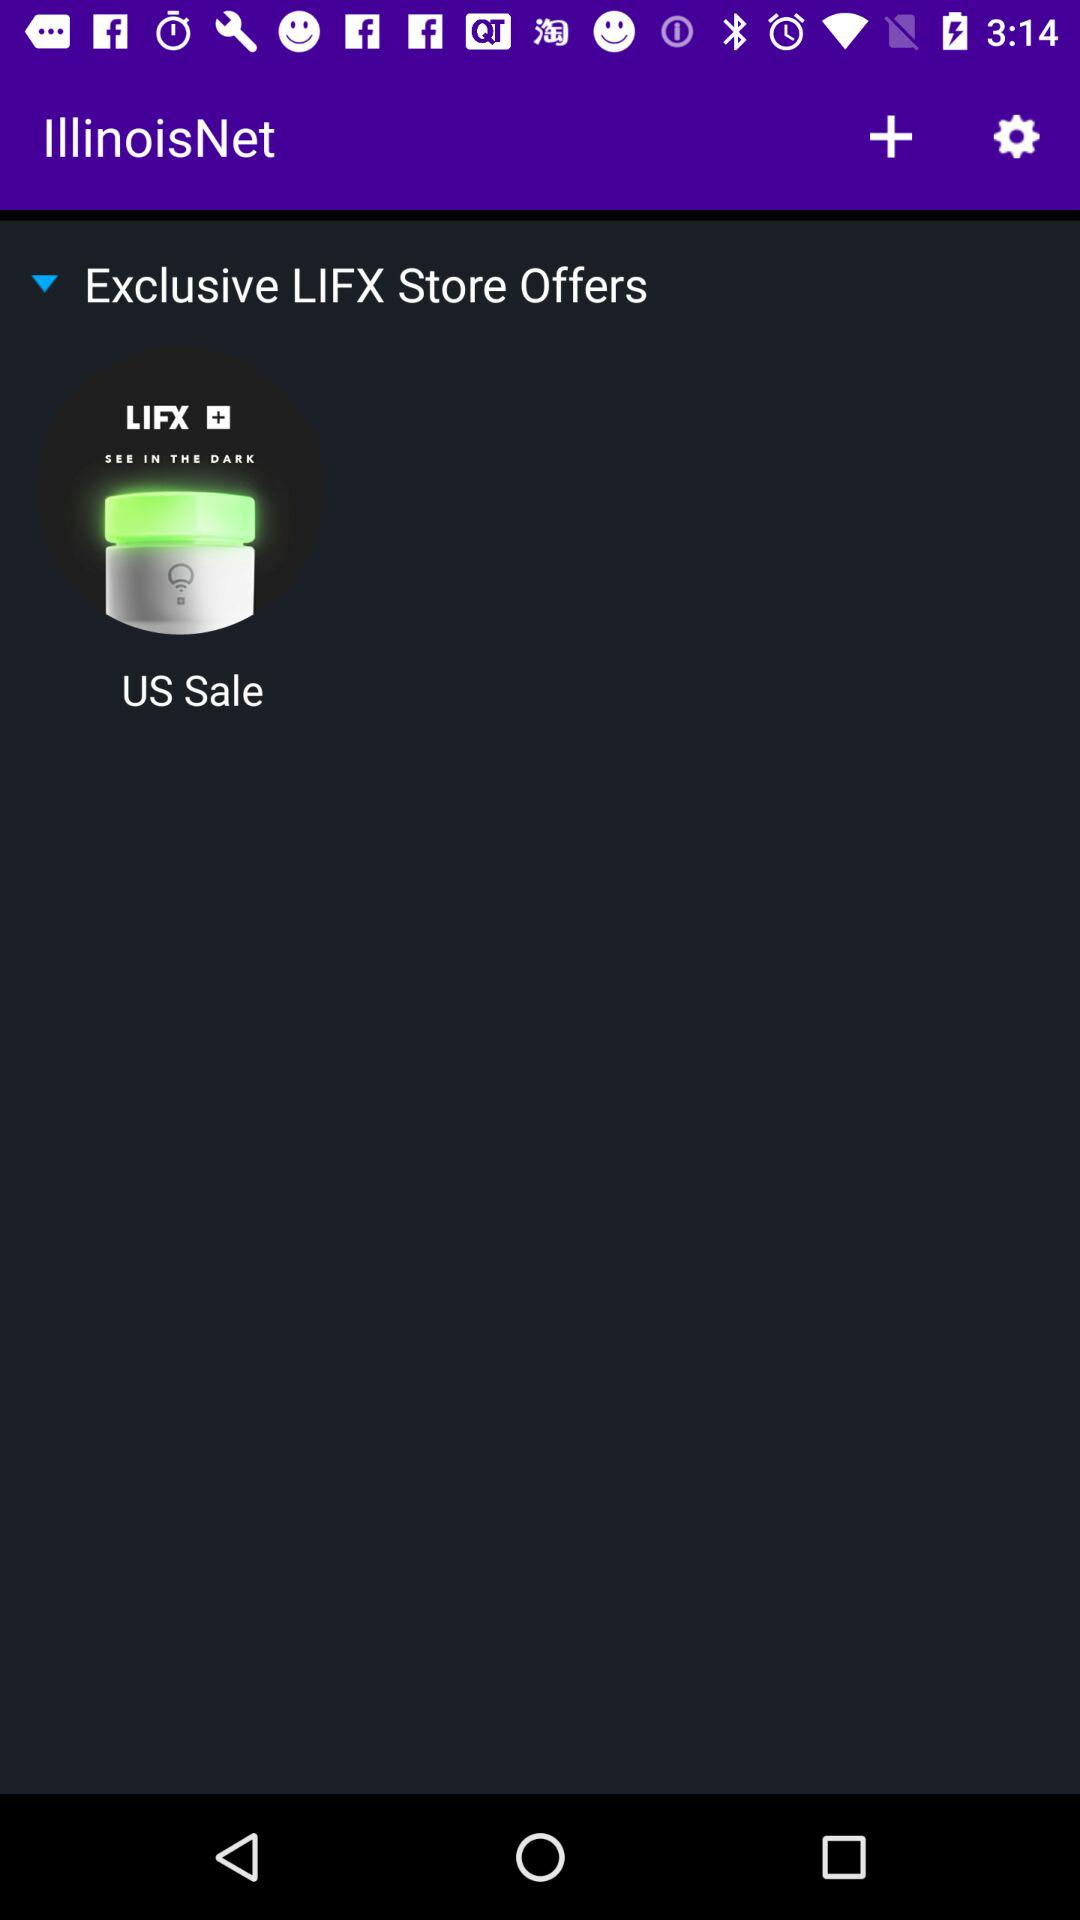What is the application name? The application name is "IllinoisNet". 